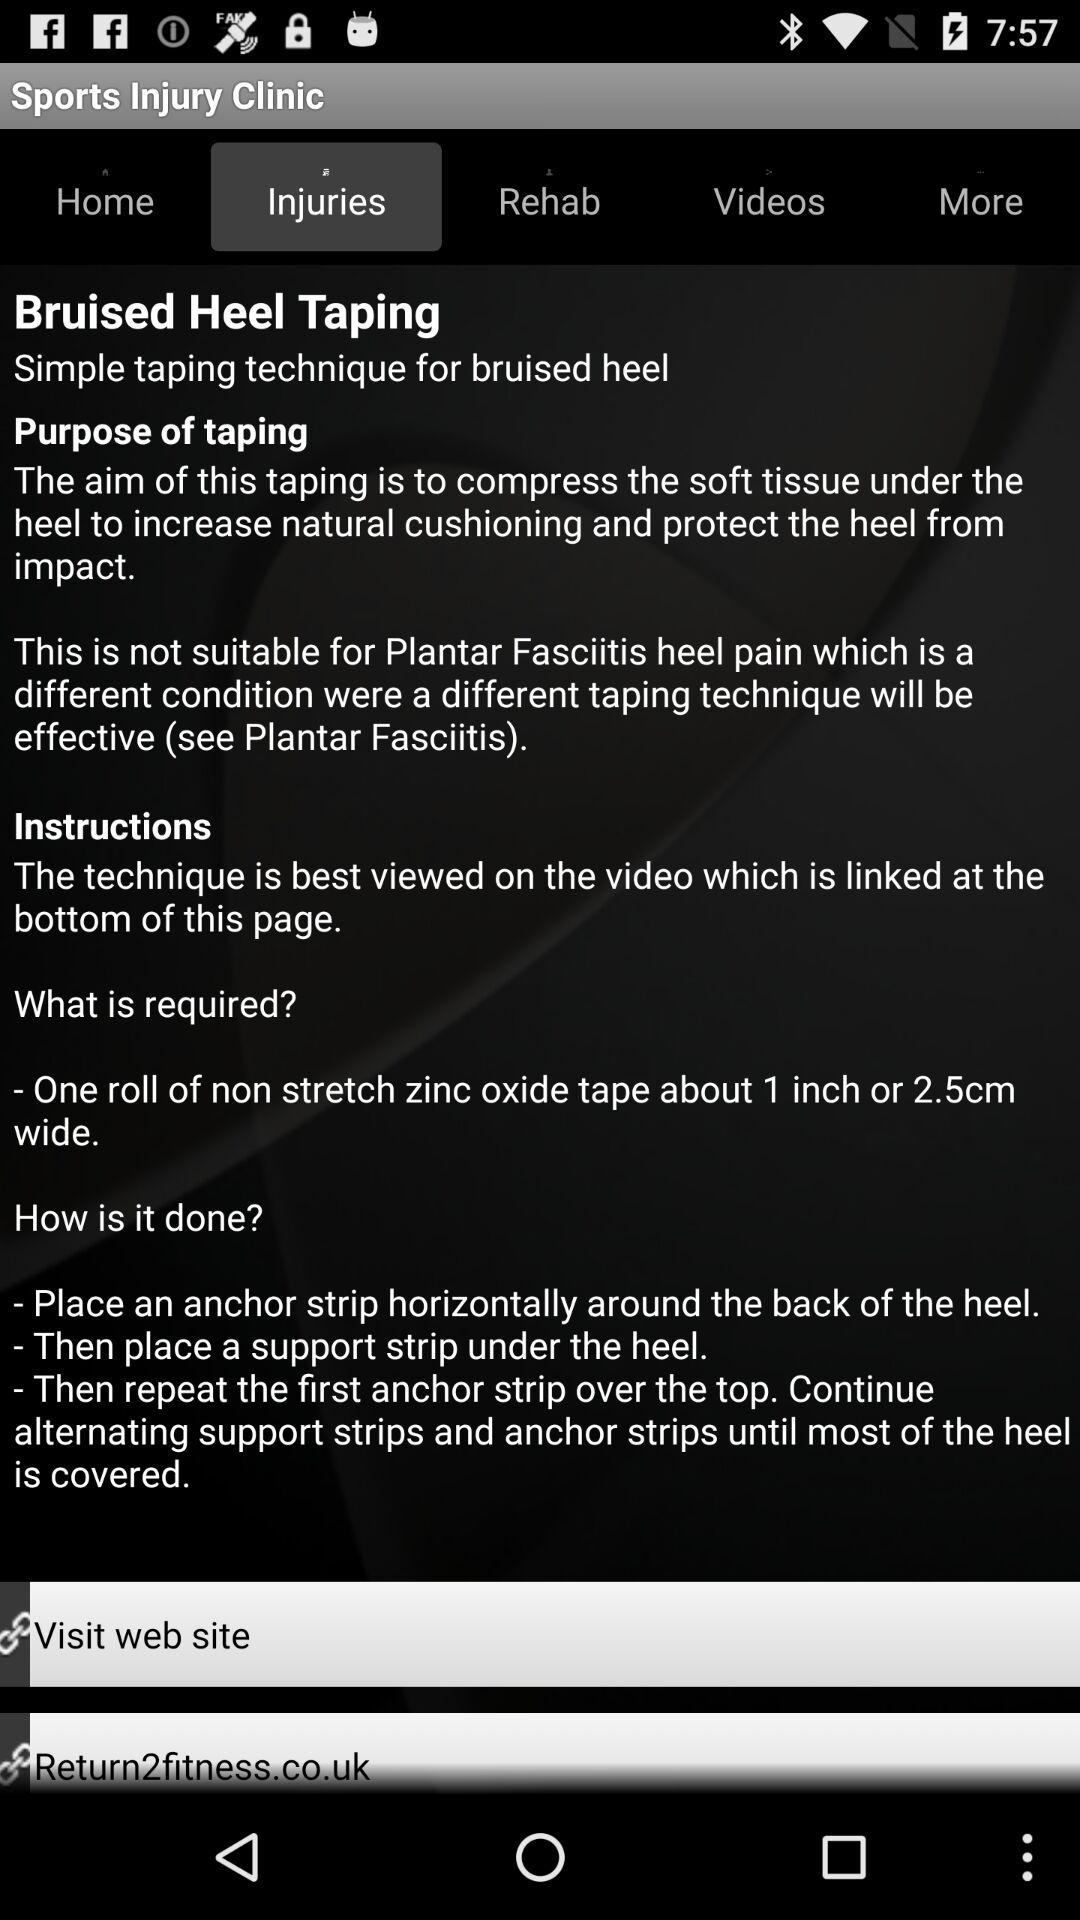What is bruised heel taping? Bruised heels Taping is a simple taping technique for bruised heel. 